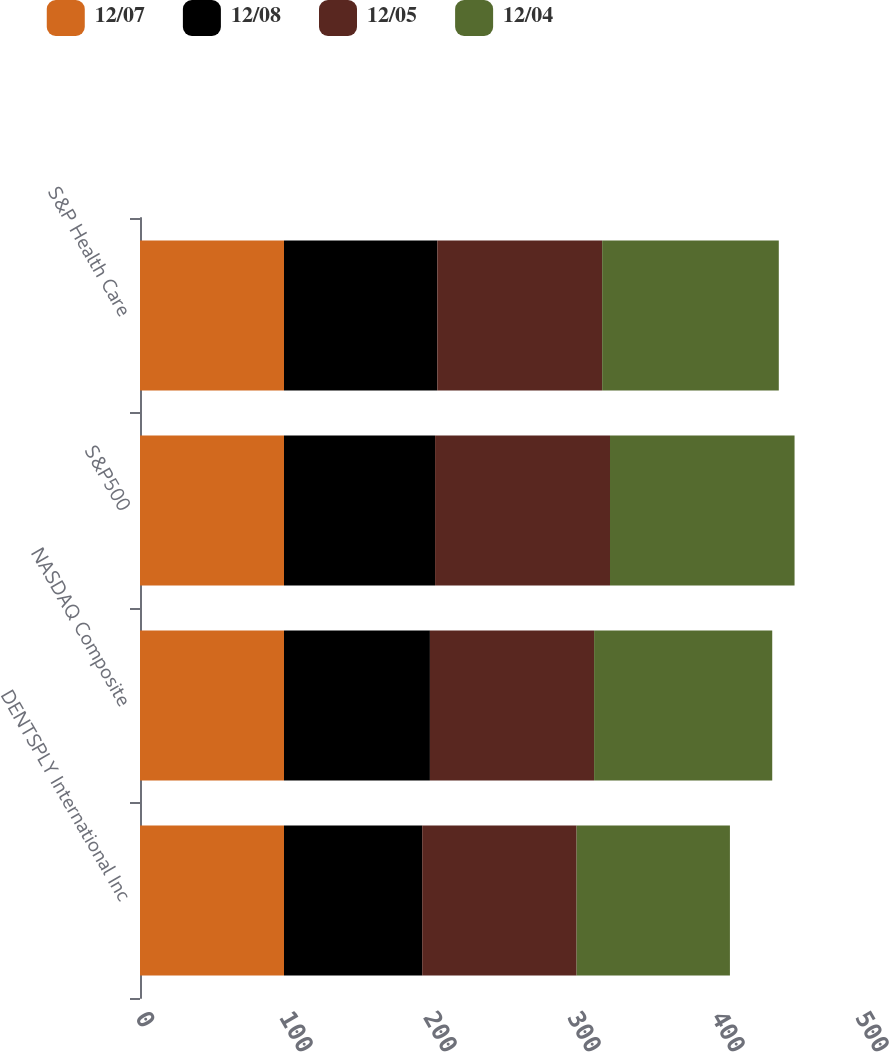<chart> <loc_0><loc_0><loc_500><loc_500><stacked_bar_chart><ecel><fcel>DENTSPLY International Inc<fcel>NASDAQ Composite<fcel>S&P500<fcel>S&P Health Care<nl><fcel>12/07<fcel>100<fcel>100<fcel>100<fcel>100<nl><fcel>12/08<fcel>95.97<fcel>101.33<fcel>104.91<fcel>106.46<nl><fcel>12/05<fcel>107.24<fcel>114.01<fcel>121.48<fcel>114.48<nl><fcel>12/04<fcel>106.46<fcel>123.71<fcel>128.16<fcel>122.67<nl></chart> 